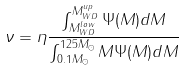Convert formula to latex. <formula><loc_0><loc_0><loc_500><loc_500>\nu = \eta \frac { \int _ { M _ { W D } ^ { l o w } } ^ { M _ { W D } ^ { u p } } \Psi ( M ) d M } { \int _ { 0 . 1 M _ { \odot } } ^ { 1 2 5 M _ { \odot } } M \Psi ( M ) d M }</formula> 